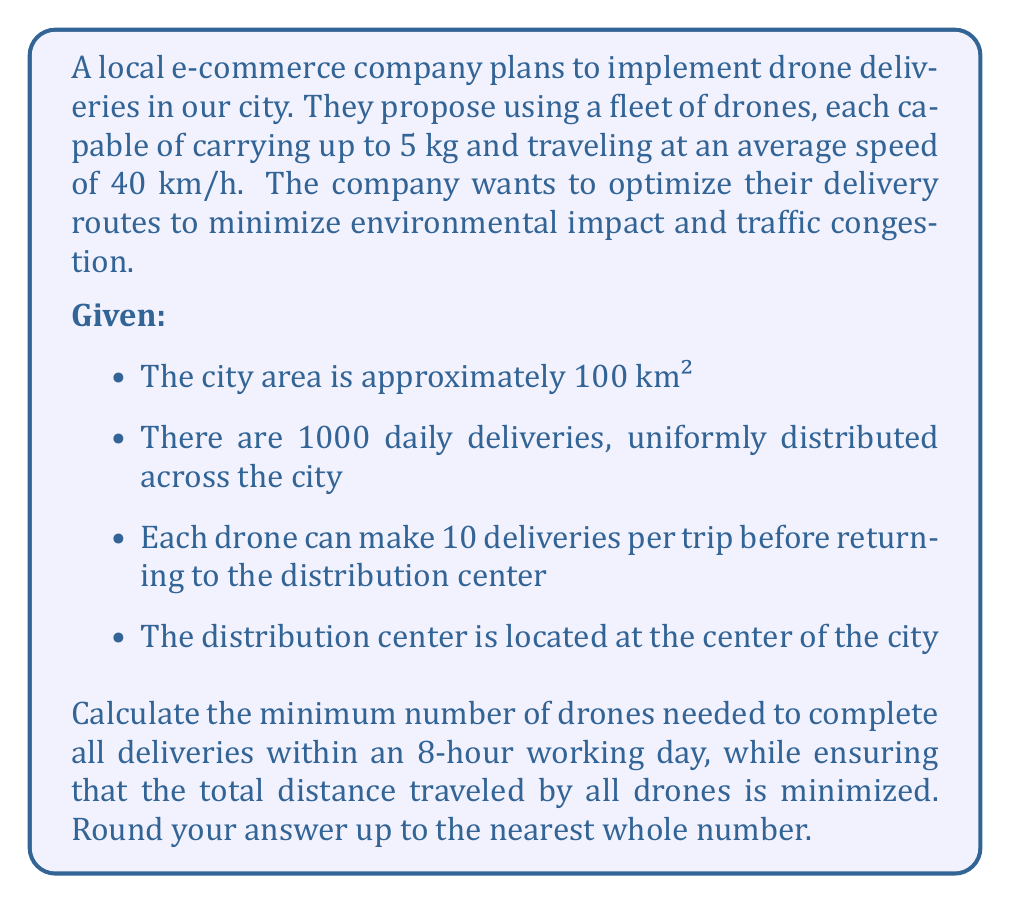Can you answer this question? To solve this optimization problem, we need to follow these steps:

1. Calculate the average distance per delivery:
   The city area is a square with side length $\sqrt{100} = 10$ km. The average distance from the center to any point in a square is approximately 0.383 times the side length.
   Average distance per delivery = $0.383 \times 10 = 3.83$ km

2. Calculate the total distance traveled per drone per trip:
   Distance per trip = $(3.83 \times 10) \times 2 = 76.6$ km (multiplied by 2 for round trip)

3. Calculate the time taken per trip:
   Time per trip = $\frac{76.6}{40} = 1.915$ hours

4. Calculate the number of trips a drone can make in 8 hours:
   Trips per day = $\frac{8}{1.915} \approx 4.18$ trips

5. Calculate the number of deliveries a single drone can make per day:
   Deliveries per drone per day = $4.18 \times 10 = 41.8$ deliveries

6. Calculate the minimum number of drones needed:
   Minimum drones = $\frac{1000}{41.8} \approx 23.92$

7. Round up to the nearest whole number:
   Minimum drones = 24

This solution minimizes the total distance traveled by all drones because:
a) It uses the minimum number of drones required to complete all deliveries within the working day.
b) Each drone makes the maximum number of deliveries possible per trip, reducing the number of return trips to the distribution center.
c) The calculation assumes optimal routing for each drone's trip, minimizing the distance traveled for each set of 10 deliveries.
Answer: 24 drones 